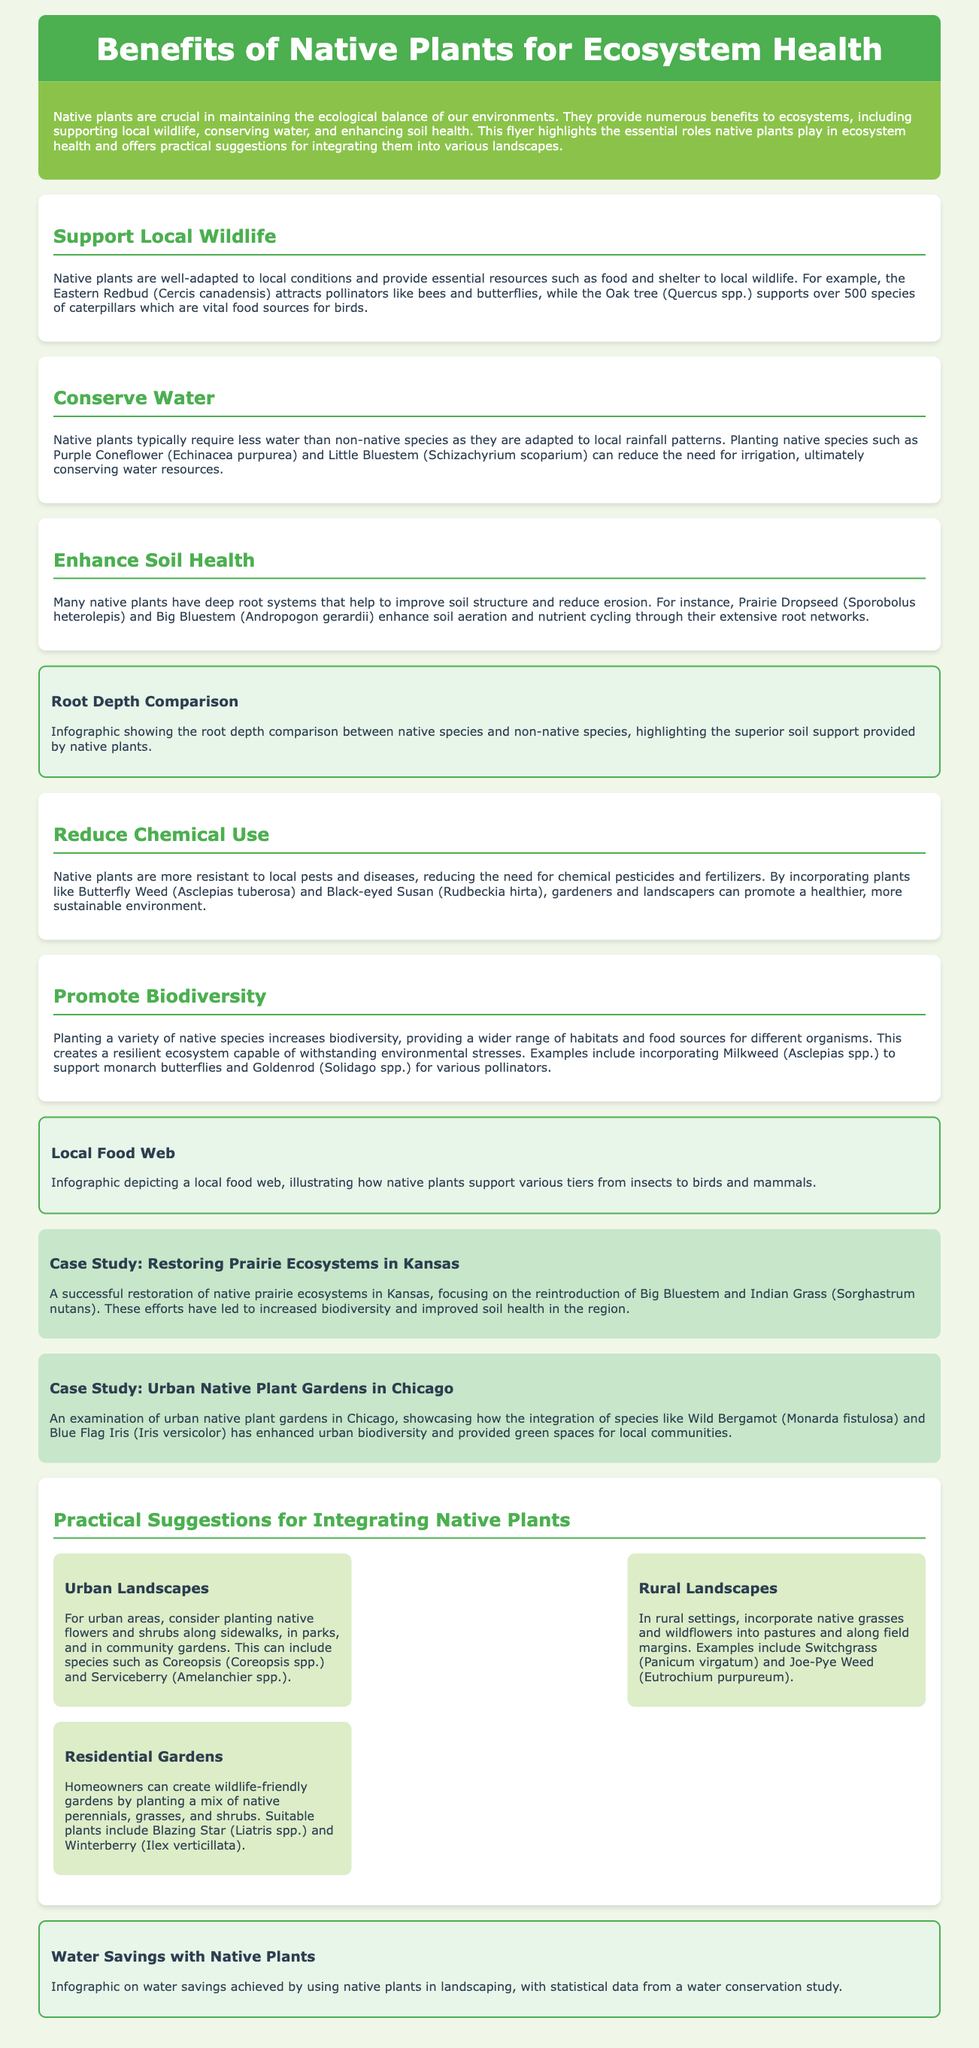What is the primary focus of the flyer? The primary focus of the flyer is to highlight the benefits of native plants for ecosystem health and provide practical suggestions for their integration.
Answer: Benefits of native plants for ecosystem health Which native plant attracts pollinators according to the document? The document mentions the Eastern Redbud as a plant that attracts pollinators like bees and butterflies.
Answer: Eastern Redbud How many species of caterpillars does the Oak tree support? The Oak tree supports over 500 species of caterpillars, as stated in the document.
Answer: 500 What is one practical suggestion for urban landscapes? The flyer suggests planting native flowers and shrubs along sidewalks, in parks, and in community gardens for urban areas.
Answer: Plant native flowers and shrubs Which case study focuses on urban native plant gardens? The case study that focuses on urban native plant gardens is the one examining the gardens in Chicago.
Answer: Urban Native Plant Gardens in Chicago What effect do native plants have on chemical use? Native plants reduce the need for chemical pesticides and fertilizers due to their resistance to local pests and diseases.
Answer: Reduce Name one benefit of deep-rooted native plants. Deep-rooted native plants improve soil structure and reduce erosion.
Answer: Improve soil structure What is the background color of the intro section? The background color of the intro section is green (#8BC34A).
Answer: Green What type of infographic is included regarding water savings? The flyer includes an infographic on water savings achieved by using native plants in landscaping.
Answer: Water savings achieved by using native plants 